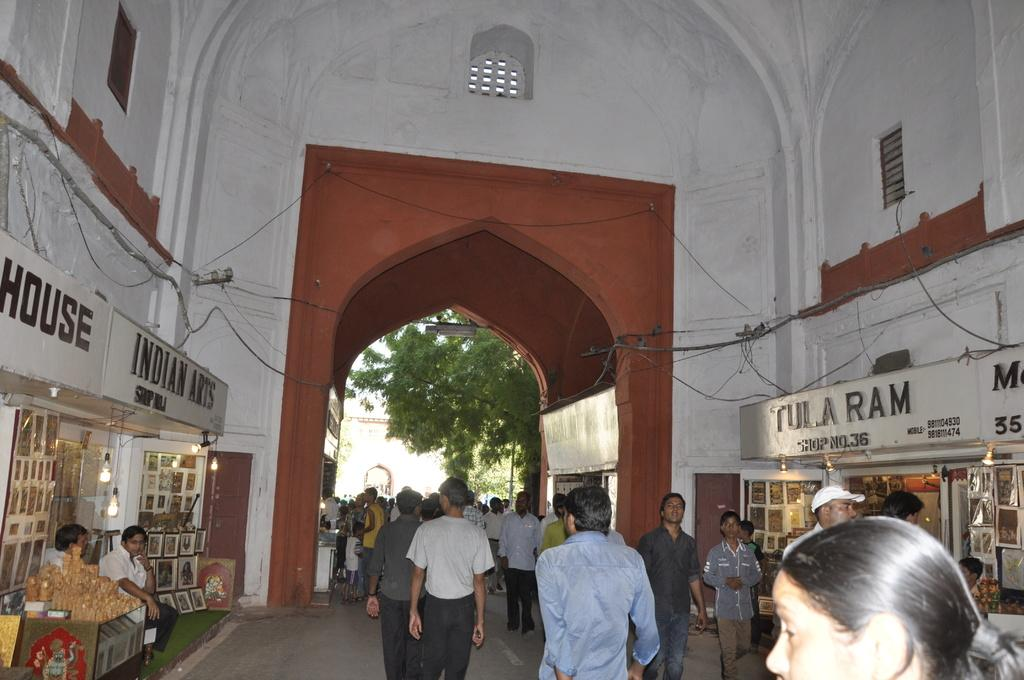What are the persons in the image doing? The persons in the image are walking. What is located on either side of the persons? There are stores on either side of the persons. What can be seen in the background of the image? There are trees and other objects visible in the background of the image. Can you tell me how many chalk pieces are lying on the ground in the image? There is no chalk present in the image, so it is not possible to determine the number of chalk pieces on the ground. What type of drum can be heard playing in the background of the image? There is no drum or any sound present in the image, so it is not possible to determine what type of drum might be playing. 